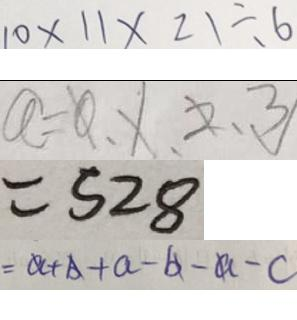Convert formula to latex. <formula><loc_0><loc_0><loc_500><loc_500>1 0 \times 1 1 \times 2 1 \div 6 
 a = 0 , 1 , 2 , 3 
 = 5 2 8 
 = a + b + a - b - a - c</formula> 